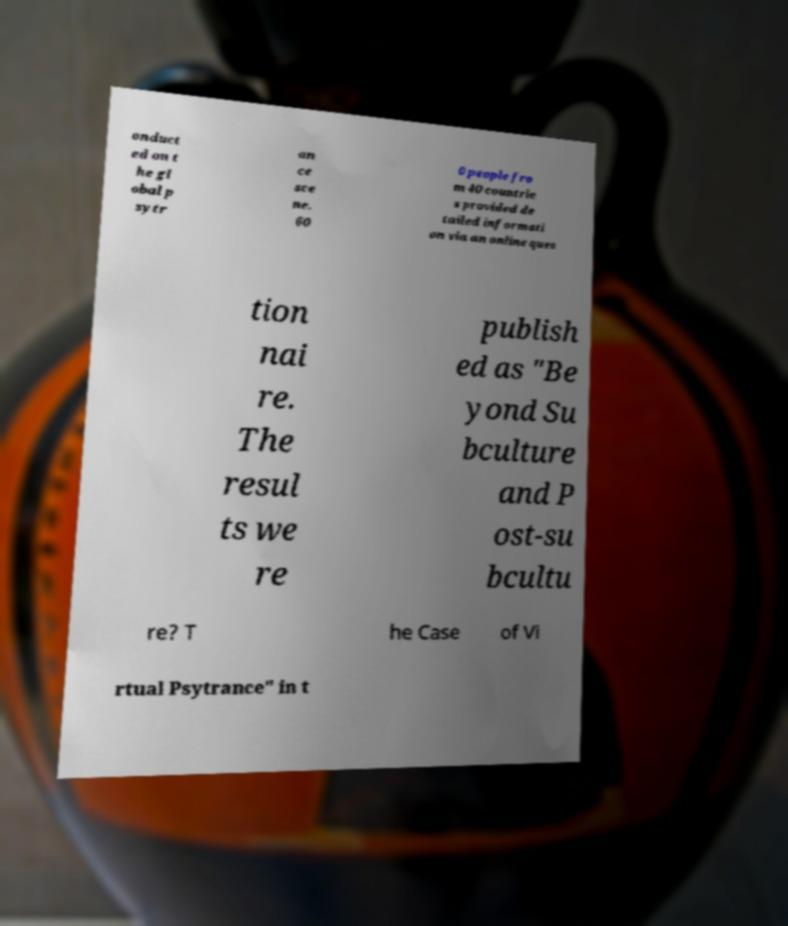Can you read and provide the text displayed in the image?This photo seems to have some interesting text. Can you extract and type it out for me? onduct ed on t he gl obal p sytr an ce sce ne. 60 0 people fro m 40 countrie s provided de tailed informati on via an online ques tion nai re. The resul ts we re publish ed as "Be yond Su bculture and P ost-su bcultu re? T he Case of Vi rtual Psytrance" in t 